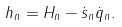Convert formula to latex. <formula><loc_0><loc_0><loc_500><loc_500>h _ { n } = H _ { n } - \dot { s } _ { n } \dot { q } _ { n } .</formula> 